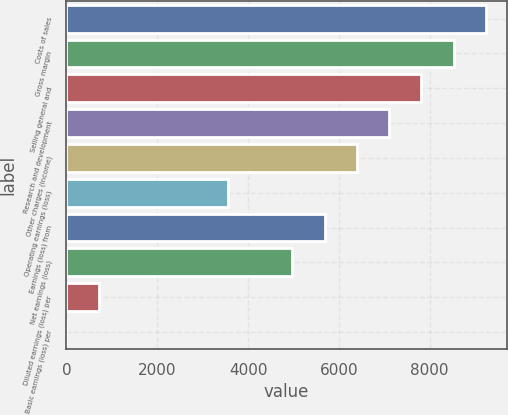<chart> <loc_0><loc_0><loc_500><loc_500><bar_chart><fcel>Costs of sales<fcel>Gross margin<fcel>Selling general and<fcel>Research and development<fcel>Other charges (income)<fcel>Operating earnings (loss)<fcel>Earnings (loss) from<fcel>Net earnings (loss)<fcel>Diluted earnings (loss) per<fcel>Basic earnings (loss) per<nl><fcel>9237.84<fcel>8527.24<fcel>7816.64<fcel>7106.04<fcel>6395.44<fcel>3553.04<fcel>5684.84<fcel>4974.24<fcel>710.64<fcel>0.04<nl></chart> 